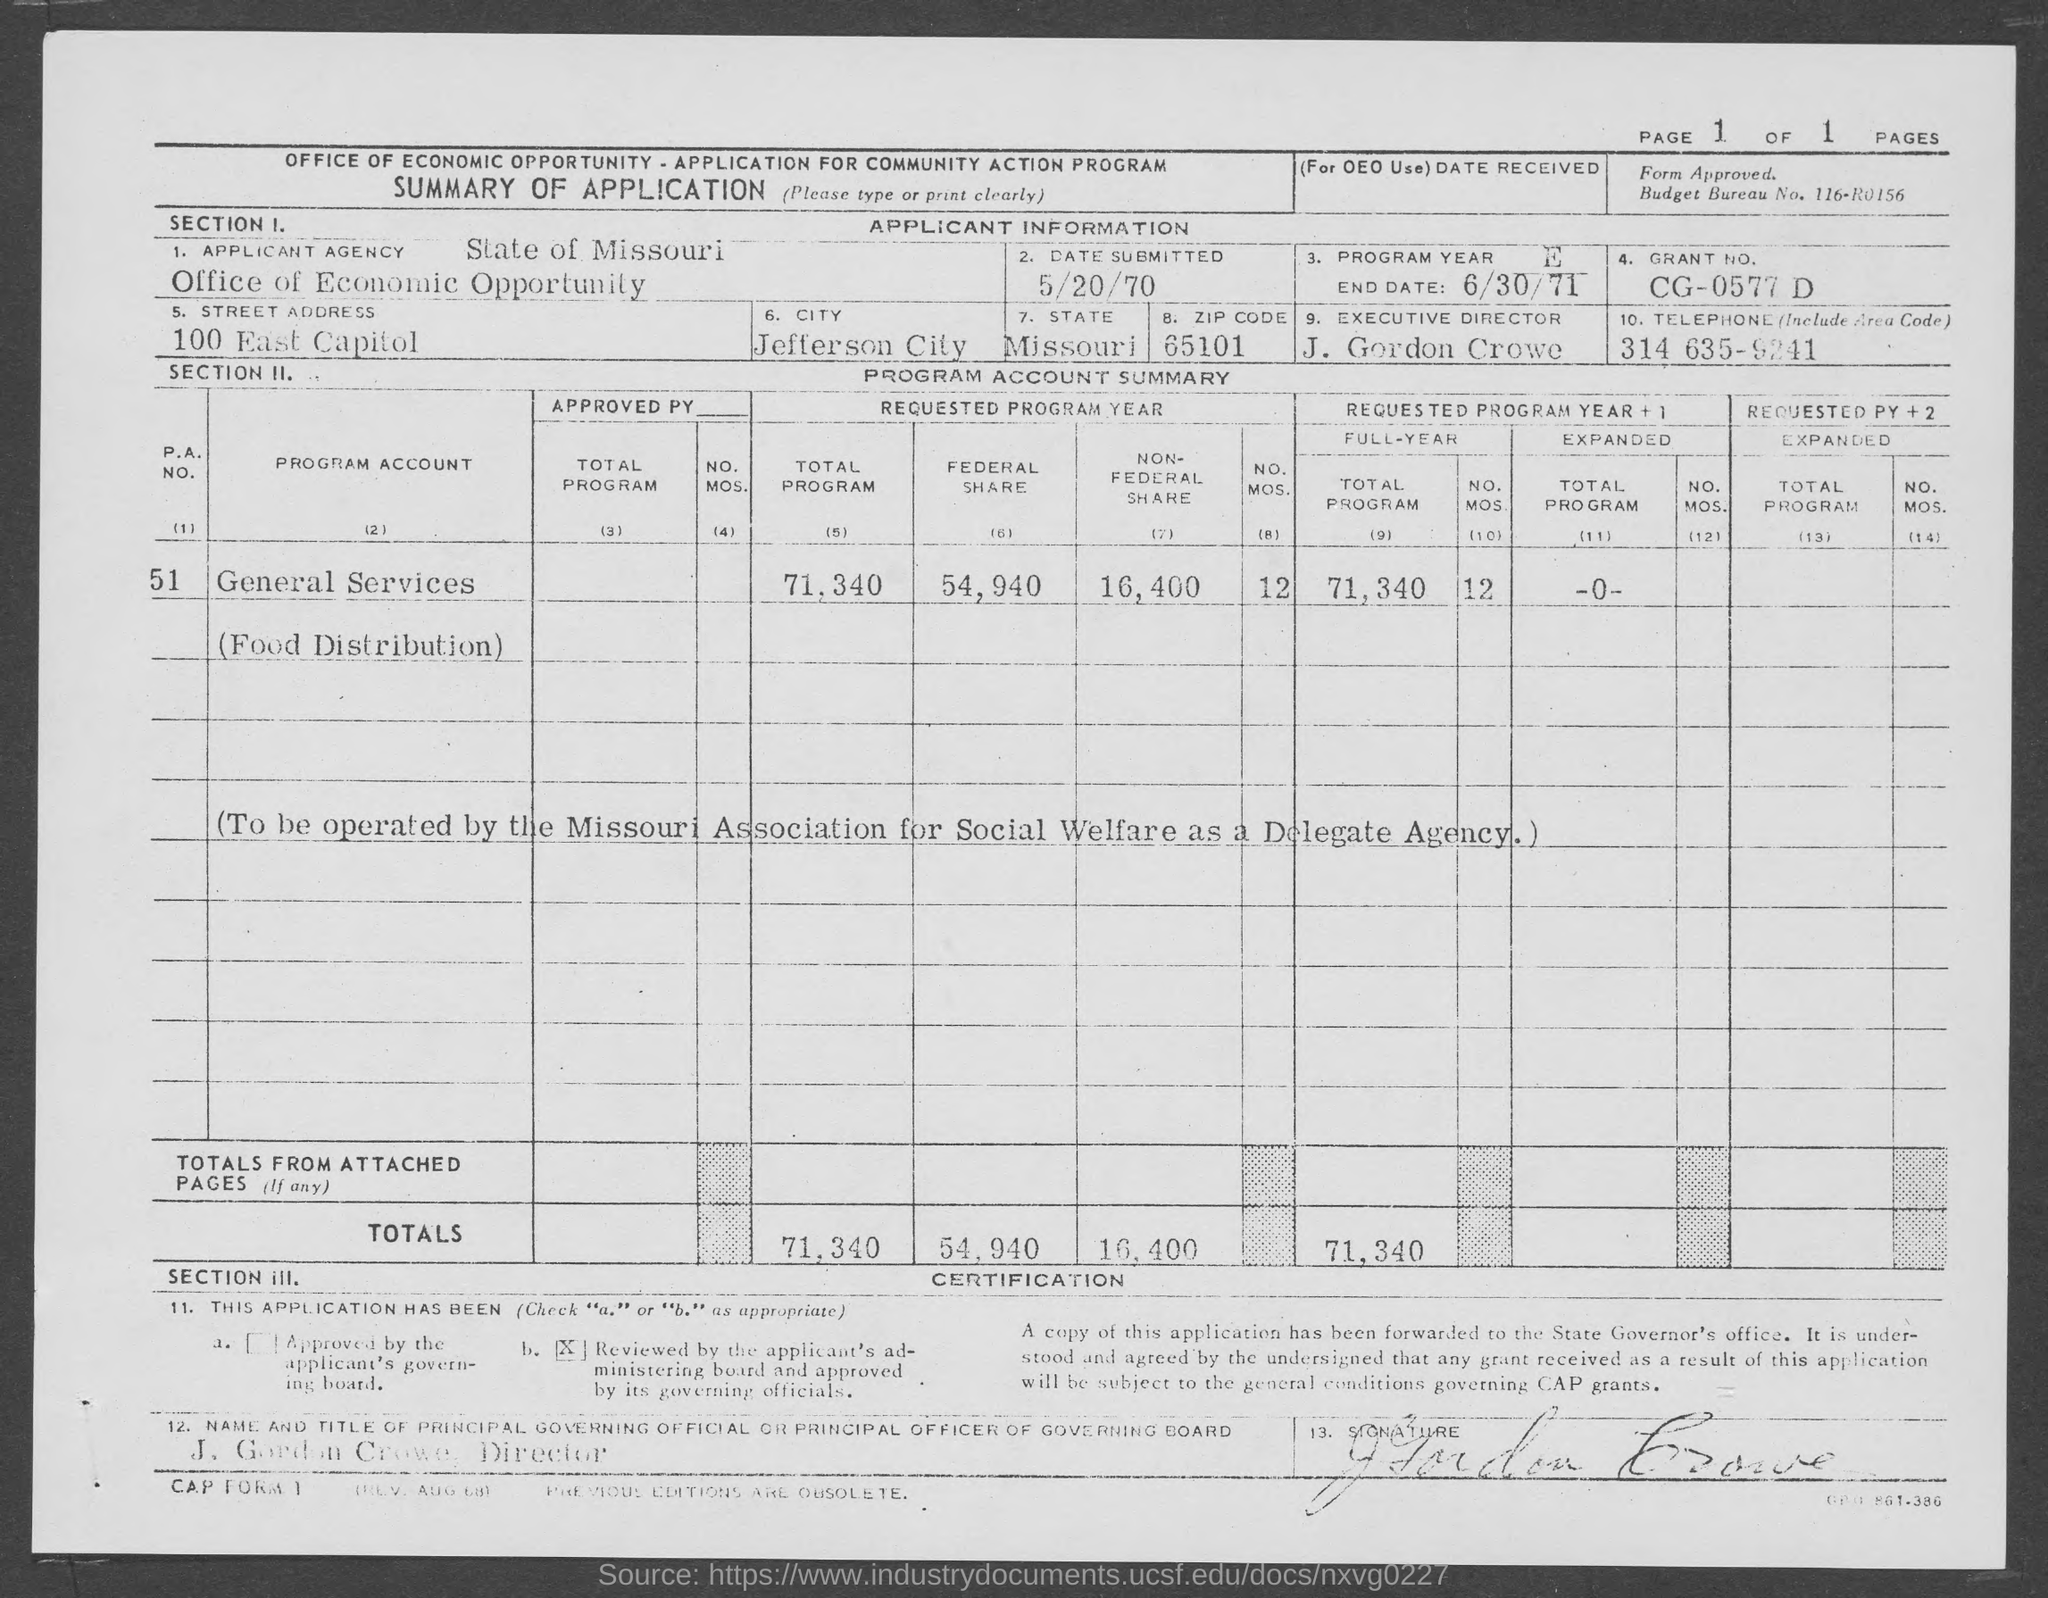What is the name of the 'APPLICANT AGENCY' ?
Your answer should be compact. Office of Economic Opportunity. What is the name of the "State" mentioned in the Table?
Provide a short and direct response. Missouri. What is the name of the "City" mentioned in the Table?
Your response must be concise. Jefferson city. What is the "STREET ADDRESS" mentioned in the Table?
Ensure brevity in your answer.  100 east capitol. What is the "DATE SUBMITTED" as per the Table?
Your answer should be very brief. 5/20/70. What is the " GRANT NO." as per the Table?
Your answer should be compact. Cg-0577 d. What is the name of the "EXECUTIVE DIRECTOR" ?
Your answer should be compact. J. Gordon Crowe. What is the "TELEPHONE(Include Area Code)" number given in the Table?
Your response must be concise. 314 635-9241. What is the "PROGRAM YEAR END DATE" given in the Table?
Provide a short and direct response. 6/30/71. 